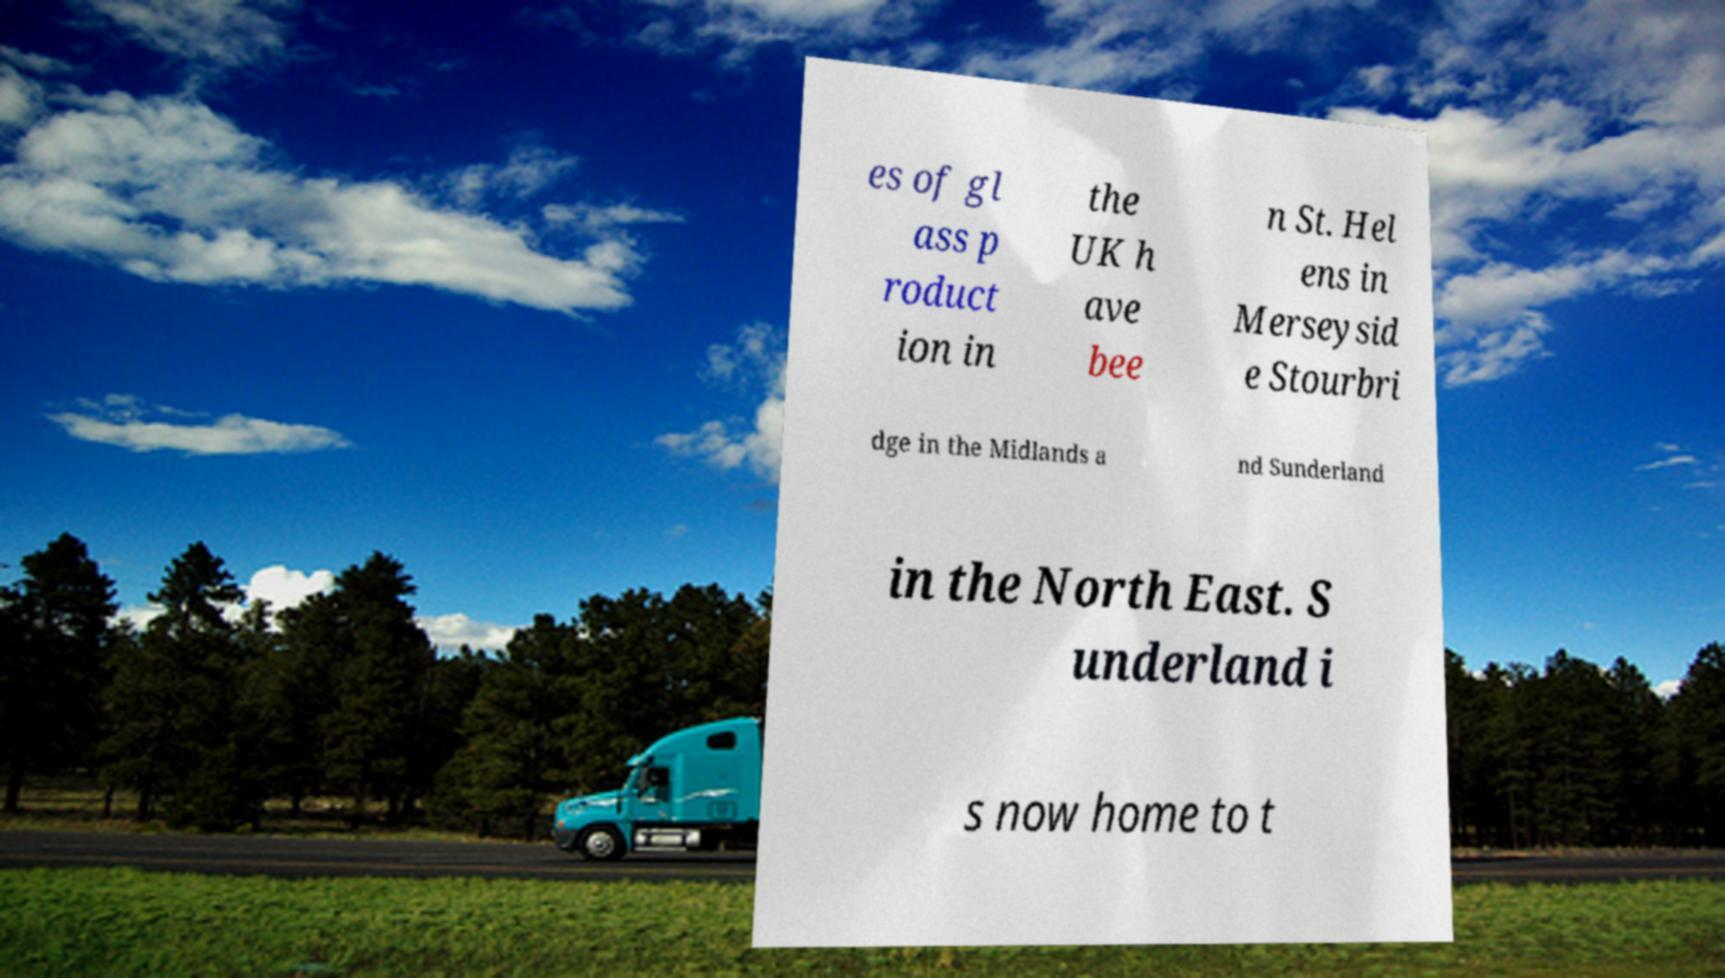Can you read and provide the text displayed in the image?This photo seems to have some interesting text. Can you extract and type it out for me? es of gl ass p roduct ion in the UK h ave bee n St. Hel ens in Merseysid e Stourbri dge in the Midlands a nd Sunderland in the North East. S underland i s now home to t 